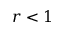<formula> <loc_0><loc_0><loc_500><loc_500>r < 1</formula> 